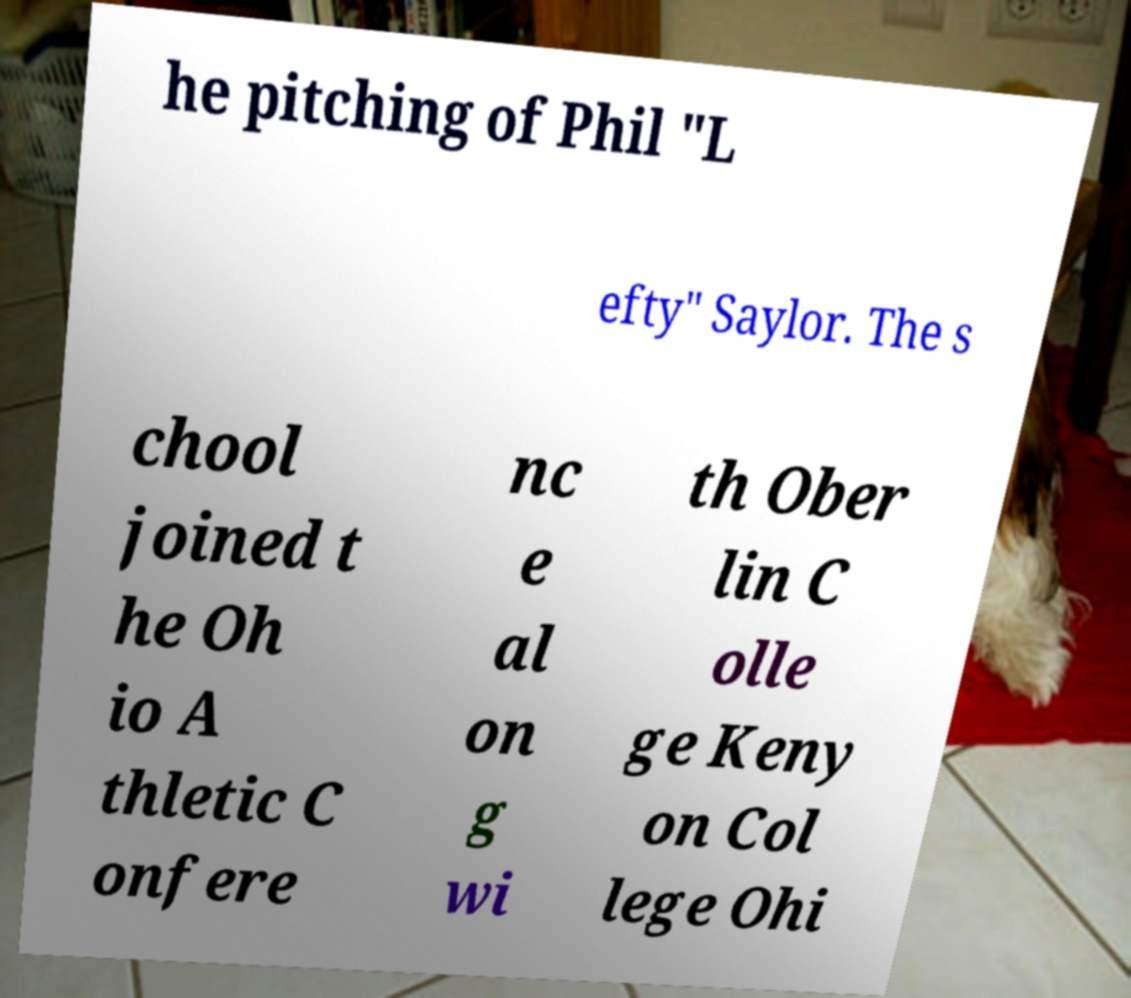There's text embedded in this image that I need extracted. Can you transcribe it verbatim? he pitching of Phil "L efty" Saylor. The s chool joined t he Oh io A thletic C onfere nc e al on g wi th Ober lin C olle ge Keny on Col lege Ohi 